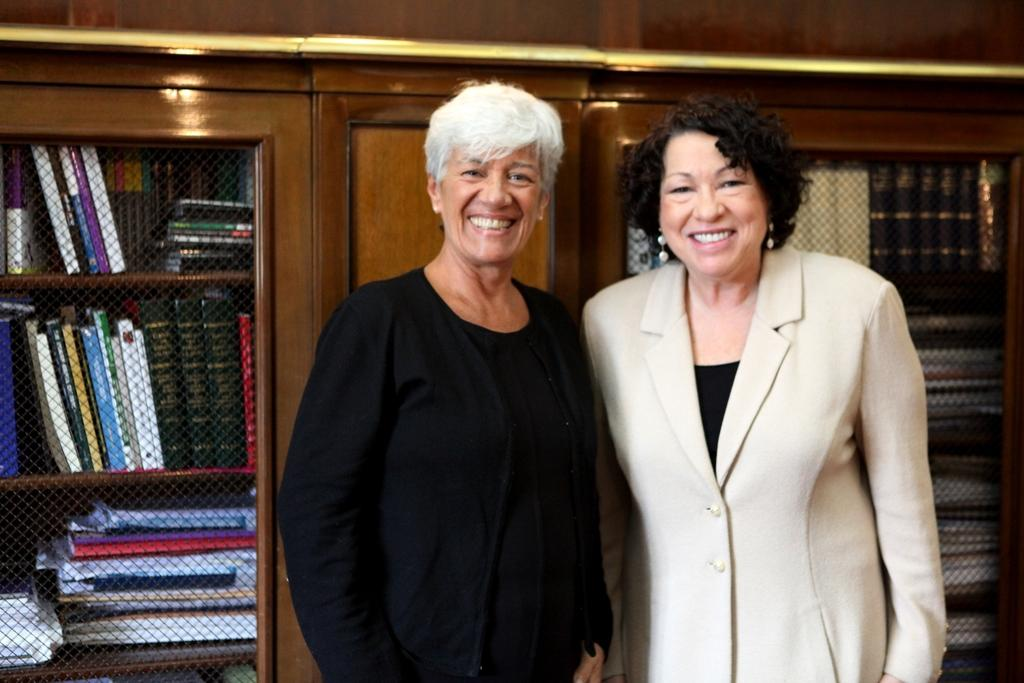How many women are in the image? There are two women in the image. What expressions do the women have on their faces? The women are standing with smiles on their faces. What can be seen behind the women in the image? There is a wooden bookshelf in the image. What is placed on the bookshelf? Books are placed on the bookshelf. How many houses are visible in the image? There are no houses visible in the image. What type of box is being used to store the books on the bookshelf? There is no box present in the image; the books are placed directly on the bookshelf. 